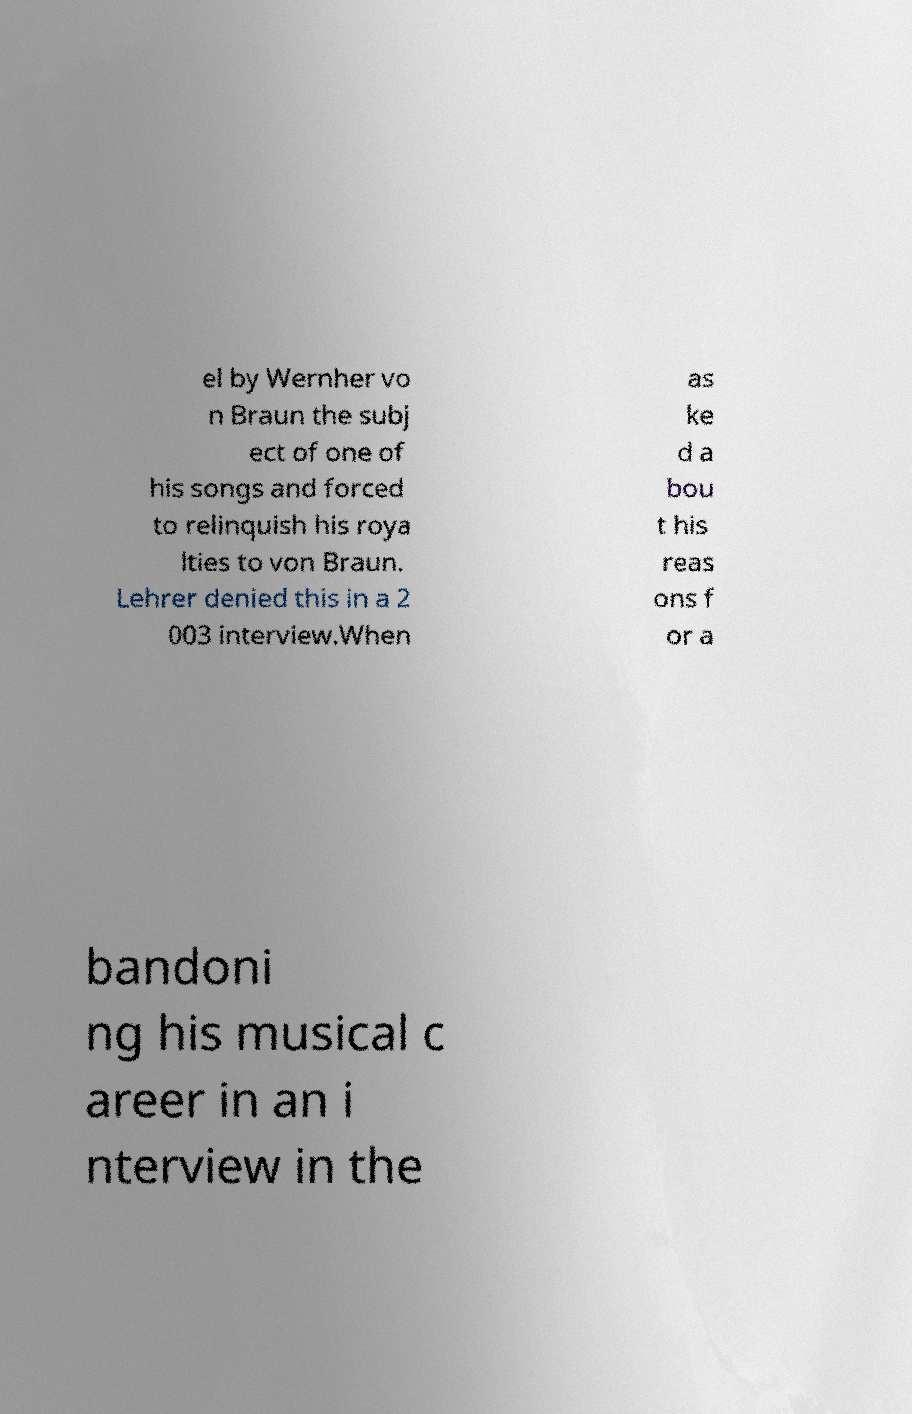What messages or text are displayed in this image? I need them in a readable, typed format. el by Wernher vo n Braun the subj ect of one of his songs and forced to relinquish his roya lties to von Braun. Lehrer denied this in a 2 003 interview.When as ke d a bou t his reas ons f or a bandoni ng his musical c areer in an i nterview in the 